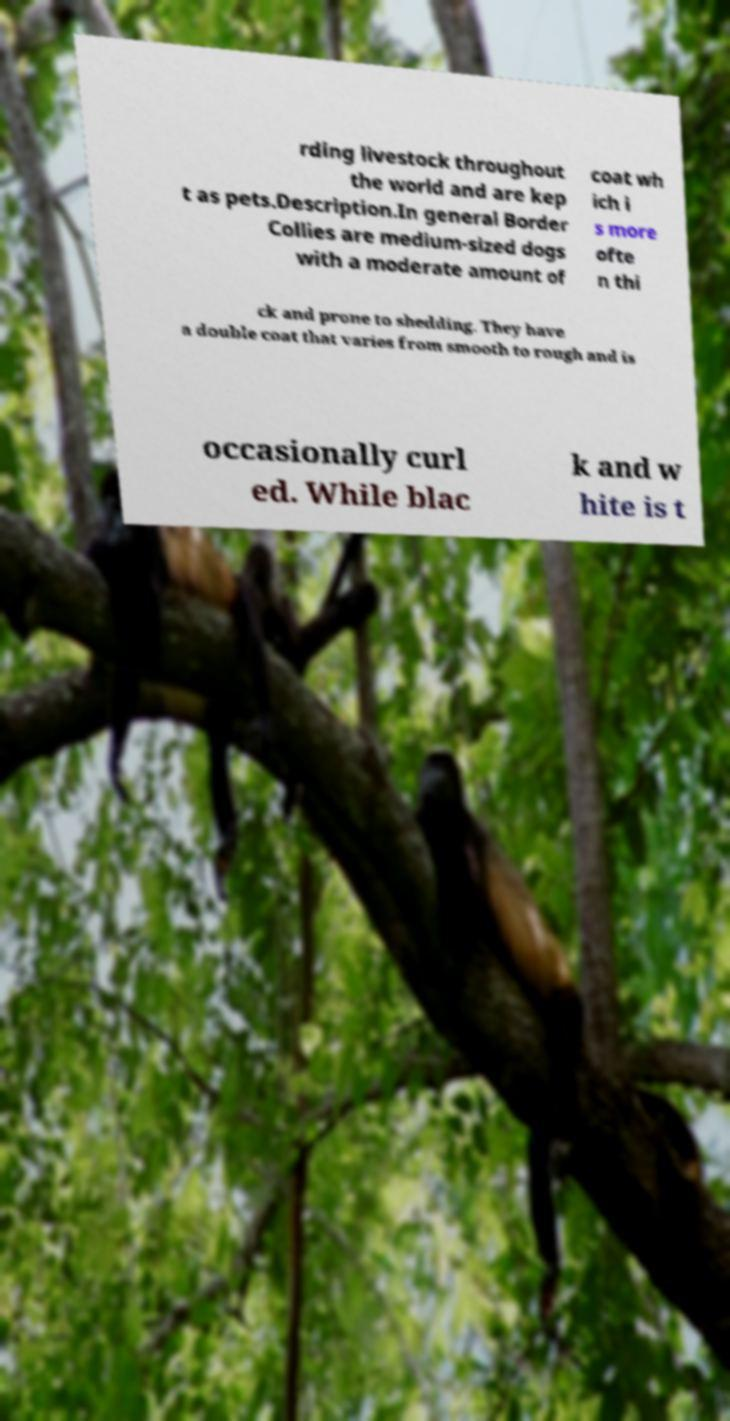For documentation purposes, I need the text within this image transcribed. Could you provide that? rding livestock throughout the world and are kep t as pets.Description.In general Border Collies are medium-sized dogs with a moderate amount of coat wh ich i s more ofte n thi ck and prone to shedding. They have a double coat that varies from smooth to rough and is occasionally curl ed. While blac k and w hite is t 